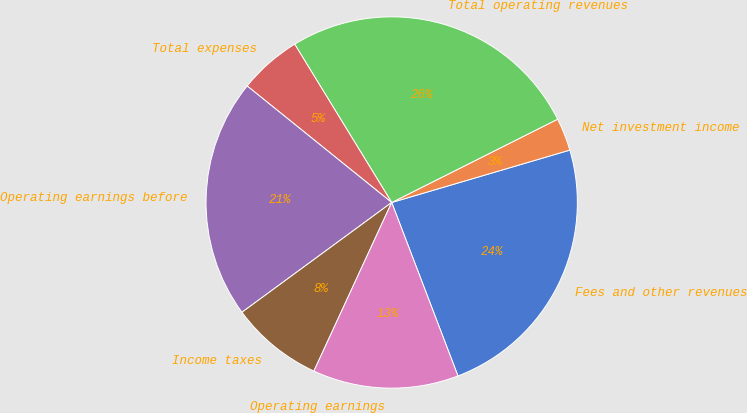Convert chart to OTSL. <chart><loc_0><loc_0><loc_500><loc_500><pie_chart><fcel>Fees and other revenues<fcel>Net investment income<fcel>Total operating revenues<fcel>Total expenses<fcel>Operating earnings before<fcel>Income taxes<fcel>Operating earnings<nl><fcel>23.75%<fcel>2.85%<fcel>26.35%<fcel>5.45%<fcel>20.87%<fcel>8.05%<fcel>12.69%<nl></chart> 